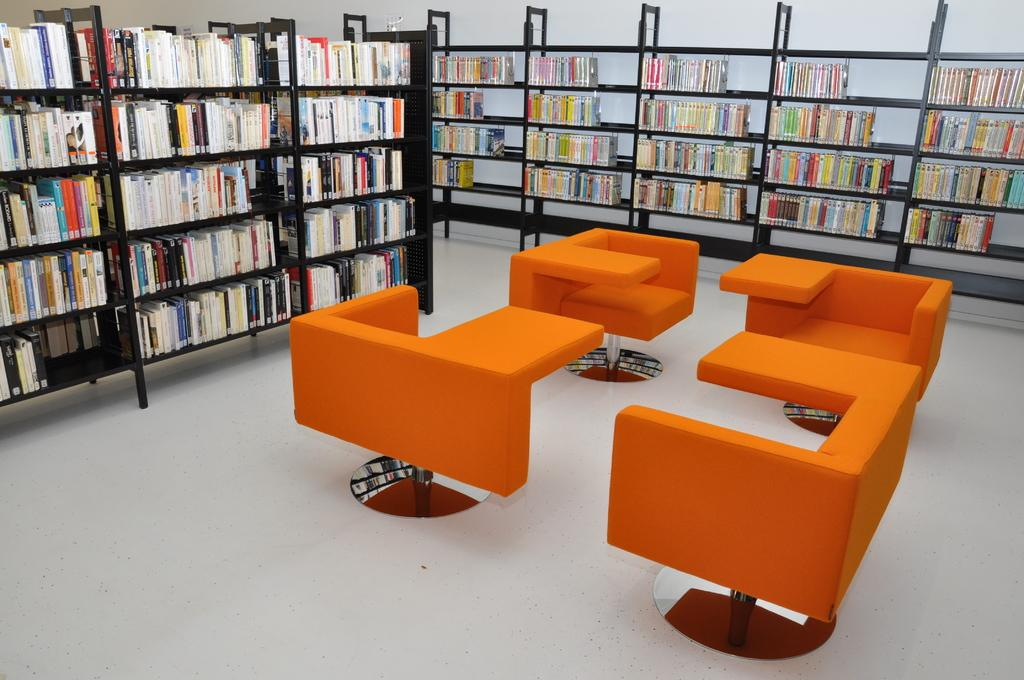What type of furniture is visible in the image? There are sofas in the image. What other type of furniture can be seen in the image? There are cupboards in the image. What items are stored in the cupboards? Books are present in the cupboards. What can be seen in the background of the image? The background of the image includes a wall. What is the color of the wall? The wall is off-white in color. Where is the image taken? The image is taken in a hall. Can you see the faces of the family members in the image? There is no reference to a family or faces in the image; it features sofas, cupboards, books, and a wall in a hall. 